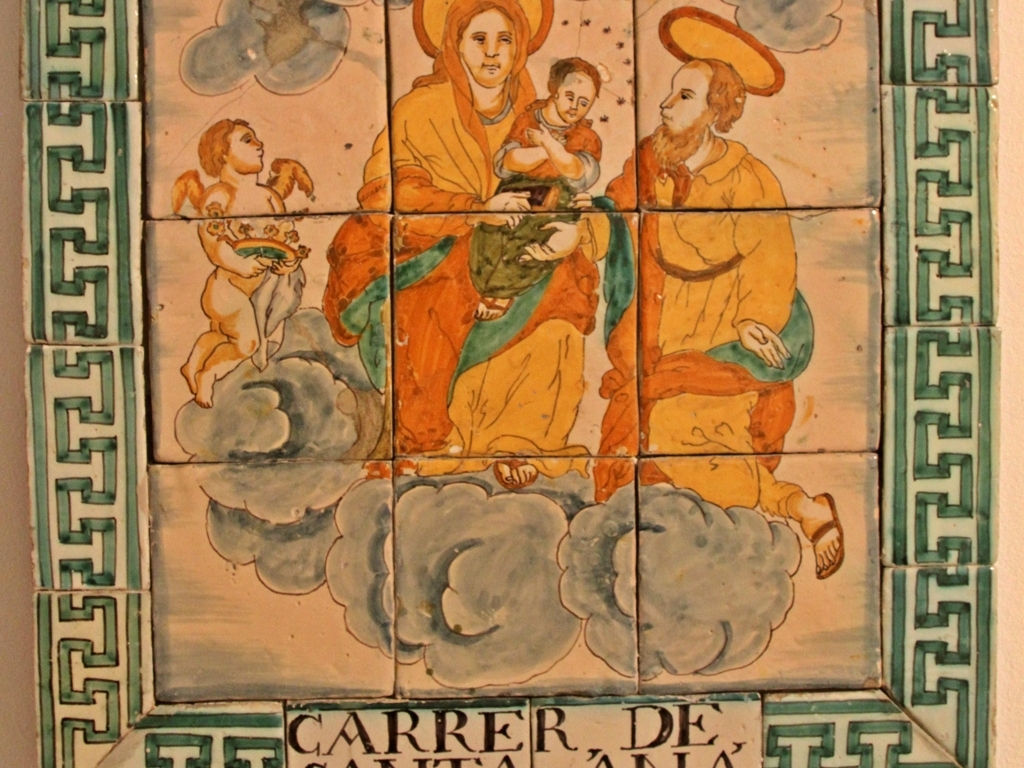Is the image pixelated?
A. No
B. Yes
Answer with the option's letter from the given choices directly.
 A. 